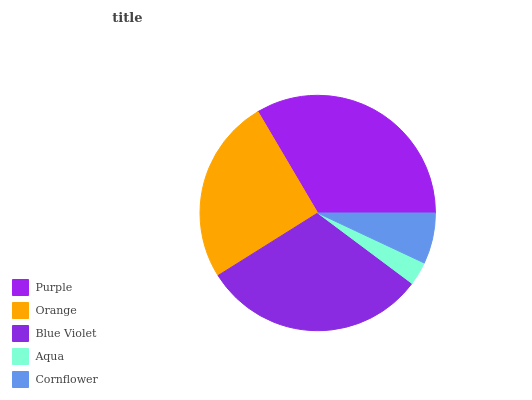Is Aqua the minimum?
Answer yes or no. Yes. Is Purple the maximum?
Answer yes or no. Yes. Is Orange the minimum?
Answer yes or no. No. Is Orange the maximum?
Answer yes or no. No. Is Purple greater than Orange?
Answer yes or no. Yes. Is Orange less than Purple?
Answer yes or no. Yes. Is Orange greater than Purple?
Answer yes or no. No. Is Purple less than Orange?
Answer yes or no. No. Is Orange the high median?
Answer yes or no. Yes. Is Orange the low median?
Answer yes or no. Yes. Is Purple the high median?
Answer yes or no. No. Is Blue Violet the low median?
Answer yes or no. No. 